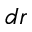<formula> <loc_0><loc_0><loc_500><loc_500>d r</formula> 